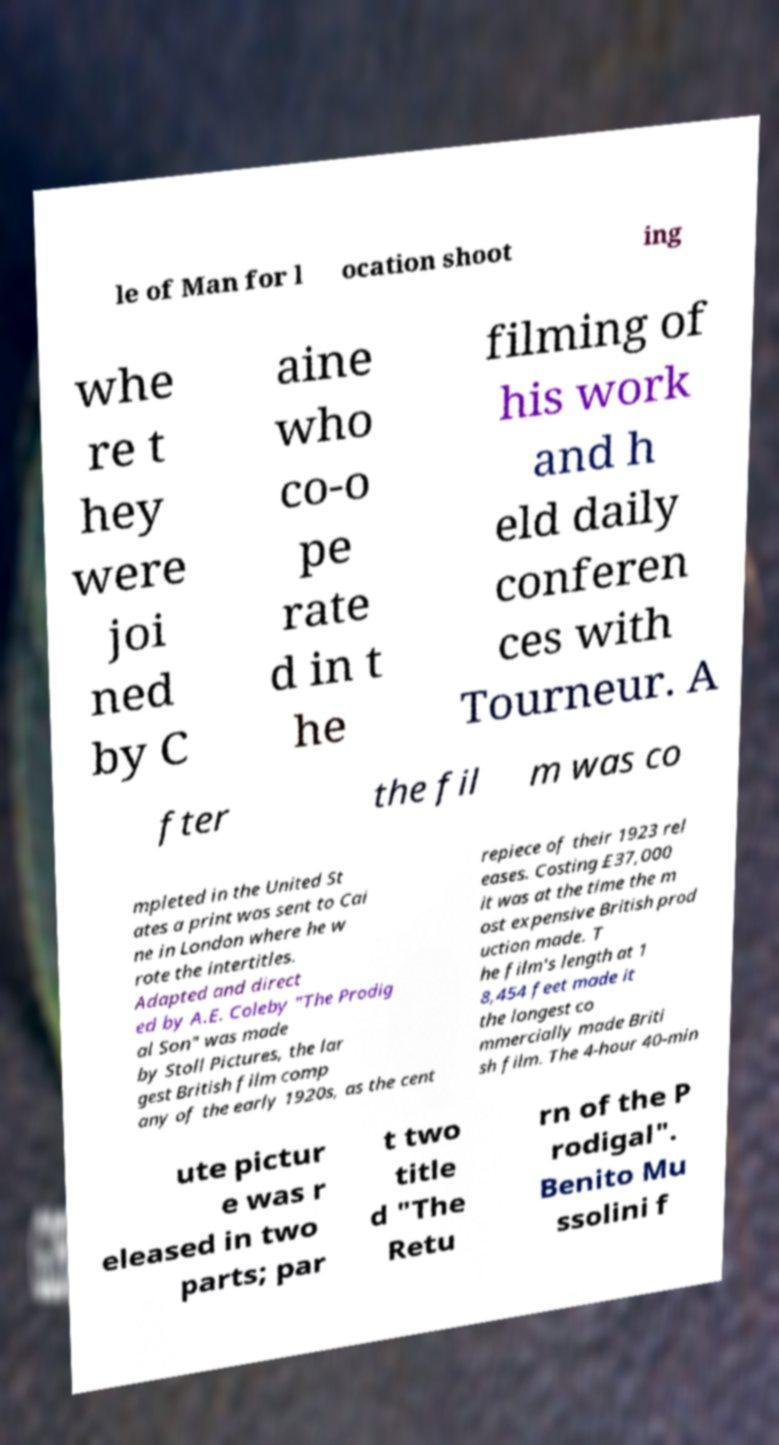What messages or text are displayed in this image? I need them in a readable, typed format. le of Man for l ocation shoot ing whe re t hey were joi ned by C aine who co-o pe rate d in t he filming of his work and h eld daily conferen ces with Tourneur. A fter the fil m was co mpleted in the United St ates a print was sent to Cai ne in London where he w rote the intertitles. Adapted and direct ed by A.E. Coleby "The Prodig al Son" was made by Stoll Pictures, the lar gest British film comp any of the early 1920s, as the cent repiece of their 1923 rel eases. Costing £37,000 it was at the time the m ost expensive British prod uction made. T he film's length at 1 8,454 feet made it the longest co mmercially made Briti sh film. The 4-hour 40-min ute pictur e was r eleased in two parts; par t two title d "The Retu rn of the P rodigal". Benito Mu ssolini f 